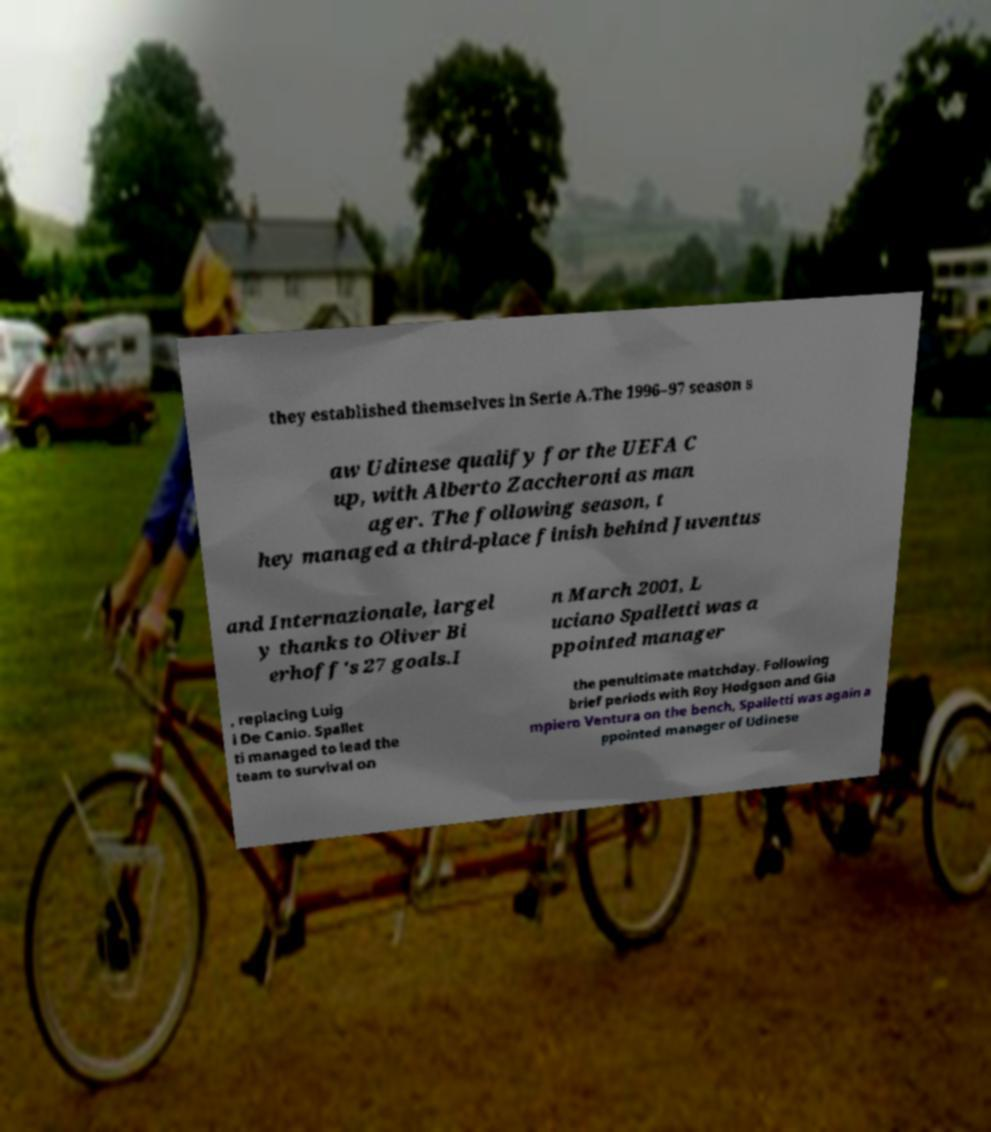Please read and relay the text visible in this image. What does it say? they established themselves in Serie A.The 1996–97 season s aw Udinese qualify for the UEFA C up, with Alberto Zaccheroni as man ager. The following season, t hey managed a third-place finish behind Juventus and Internazionale, largel y thanks to Oliver Bi erhoff's 27 goals.I n March 2001, L uciano Spalletti was a ppointed manager , replacing Luig i De Canio. Spallet ti managed to lead the team to survival on the penultimate matchday. Following brief periods with Roy Hodgson and Gia mpiero Ventura on the bench, Spalletti was again a ppointed manager of Udinese 